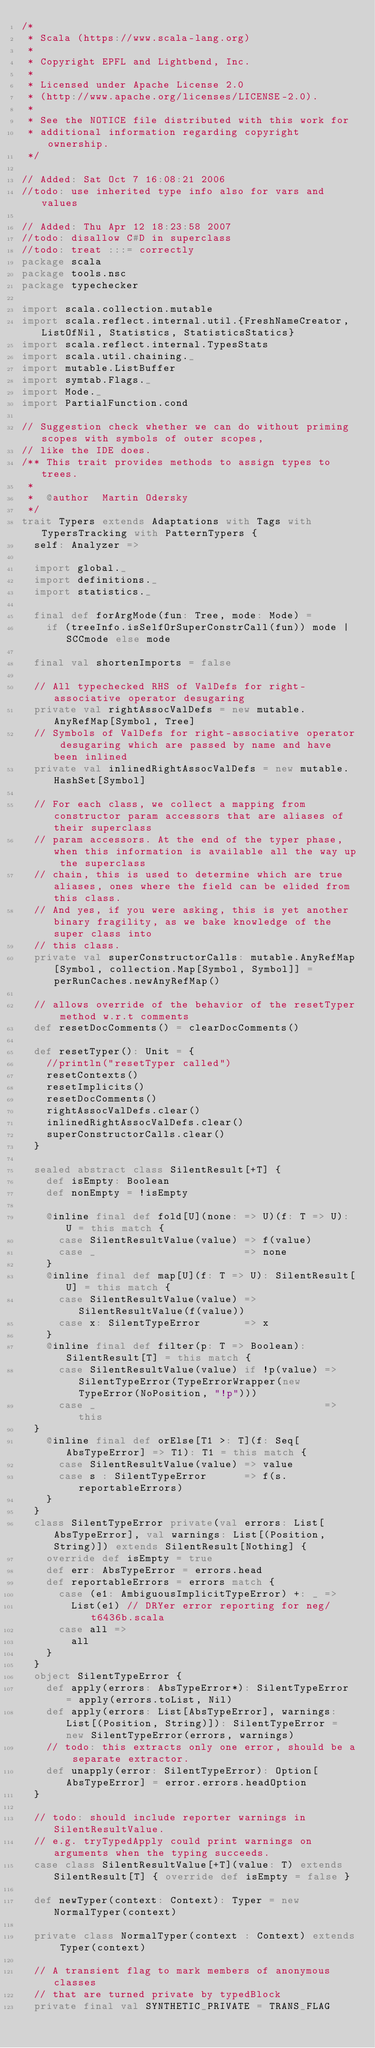Convert code to text. <code><loc_0><loc_0><loc_500><loc_500><_Scala_>/*
 * Scala (https://www.scala-lang.org)
 *
 * Copyright EPFL and Lightbend, Inc.
 *
 * Licensed under Apache License 2.0
 * (http://www.apache.org/licenses/LICENSE-2.0).
 *
 * See the NOTICE file distributed with this work for
 * additional information regarding copyright ownership.
 */

// Added: Sat Oct 7 16:08:21 2006
//todo: use inherited type info also for vars and values

// Added: Thu Apr 12 18:23:58 2007
//todo: disallow C#D in superclass
//todo: treat :::= correctly
package scala
package tools.nsc
package typechecker

import scala.collection.mutable
import scala.reflect.internal.util.{FreshNameCreator, ListOfNil, Statistics, StatisticsStatics}
import scala.reflect.internal.TypesStats
import scala.util.chaining._
import mutable.ListBuffer
import symtab.Flags._
import Mode._
import PartialFunction.cond

// Suggestion check whether we can do without priming scopes with symbols of outer scopes,
// like the IDE does.
/** This trait provides methods to assign types to trees.
 *
 *  @author  Martin Odersky
 */
trait Typers extends Adaptations with Tags with TypersTracking with PatternTypers {
  self: Analyzer =>

  import global._
  import definitions._
  import statistics._

  final def forArgMode(fun: Tree, mode: Mode) =
    if (treeInfo.isSelfOrSuperConstrCall(fun)) mode | SCCmode else mode

  final val shortenImports = false

  // All typechecked RHS of ValDefs for right-associative operator desugaring
  private val rightAssocValDefs = new mutable.AnyRefMap[Symbol, Tree]
  // Symbols of ValDefs for right-associative operator desugaring which are passed by name and have been inlined
  private val inlinedRightAssocValDefs = new mutable.HashSet[Symbol]

  // For each class, we collect a mapping from constructor param accessors that are aliases of their superclass
  // param accessors. At the end of the typer phase, when this information is available all the way up the superclass
  // chain, this is used to determine which are true aliases, ones where the field can be elided from this class.
  // And yes, if you were asking, this is yet another binary fragility, as we bake knowledge of the super class into
  // this class.
  private val superConstructorCalls: mutable.AnyRefMap[Symbol, collection.Map[Symbol, Symbol]] = perRunCaches.newAnyRefMap()

  // allows override of the behavior of the resetTyper method w.r.t comments
  def resetDocComments() = clearDocComments()

  def resetTyper(): Unit = {
    //println("resetTyper called")
    resetContexts()
    resetImplicits()
    resetDocComments()
    rightAssocValDefs.clear()
    inlinedRightAssocValDefs.clear()
    superConstructorCalls.clear()
  }

  sealed abstract class SilentResult[+T] {
    def isEmpty: Boolean
    def nonEmpty = !isEmpty

    @inline final def fold[U](none: => U)(f: T => U): U = this match {
      case SilentResultValue(value) => f(value)
      case _                        => none
    }
    @inline final def map[U](f: T => U): SilentResult[U] = this match {
      case SilentResultValue(value) => SilentResultValue(f(value))
      case x: SilentTypeError       => x
    }
    @inline final def filter(p: T => Boolean): SilentResult[T] = this match {
      case SilentResultValue(value) if !p(value) => SilentTypeError(TypeErrorWrapper(new TypeError(NoPosition, "!p")))
      case _                                     => this
  }
    @inline final def orElse[T1 >: T](f: Seq[AbsTypeError] => T1): T1 = this match {
      case SilentResultValue(value) => value
      case s : SilentTypeError      => f(s.reportableErrors)
    }
  }
  class SilentTypeError private(val errors: List[AbsTypeError], val warnings: List[(Position, String)]) extends SilentResult[Nothing] {
    override def isEmpty = true
    def err: AbsTypeError = errors.head
    def reportableErrors = errors match {
      case (e1: AmbiguousImplicitTypeError) +: _ =>
        List(e1) // DRYer error reporting for neg/t6436b.scala
      case all =>
        all
    }
  }
  object SilentTypeError {
    def apply(errors: AbsTypeError*): SilentTypeError = apply(errors.toList, Nil)
    def apply(errors: List[AbsTypeError], warnings: List[(Position, String)]): SilentTypeError = new SilentTypeError(errors, warnings)
    // todo: this extracts only one error, should be a separate extractor.
    def unapply(error: SilentTypeError): Option[AbsTypeError] = error.errors.headOption
  }

  // todo: should include reporter warnings in SilentResultValue.
  // e.g. tryTypedApply could print warnings on arguments when the typing succeeds.
  case class SilentResultValue[+T](value: T) extends SilentResult[T] { override def isEmpty = false }

  def newTyper(context: Context): Typer = new NormalTyper(context)

  private class NormalTyper(context : Context) extends Typer(context)

  // A transient flag to mark members of anonymous classes
  // that are turned private by typedBlock
  private final val SYNTHETIC_PRIVATE = TRANS_FLAG
</code> 